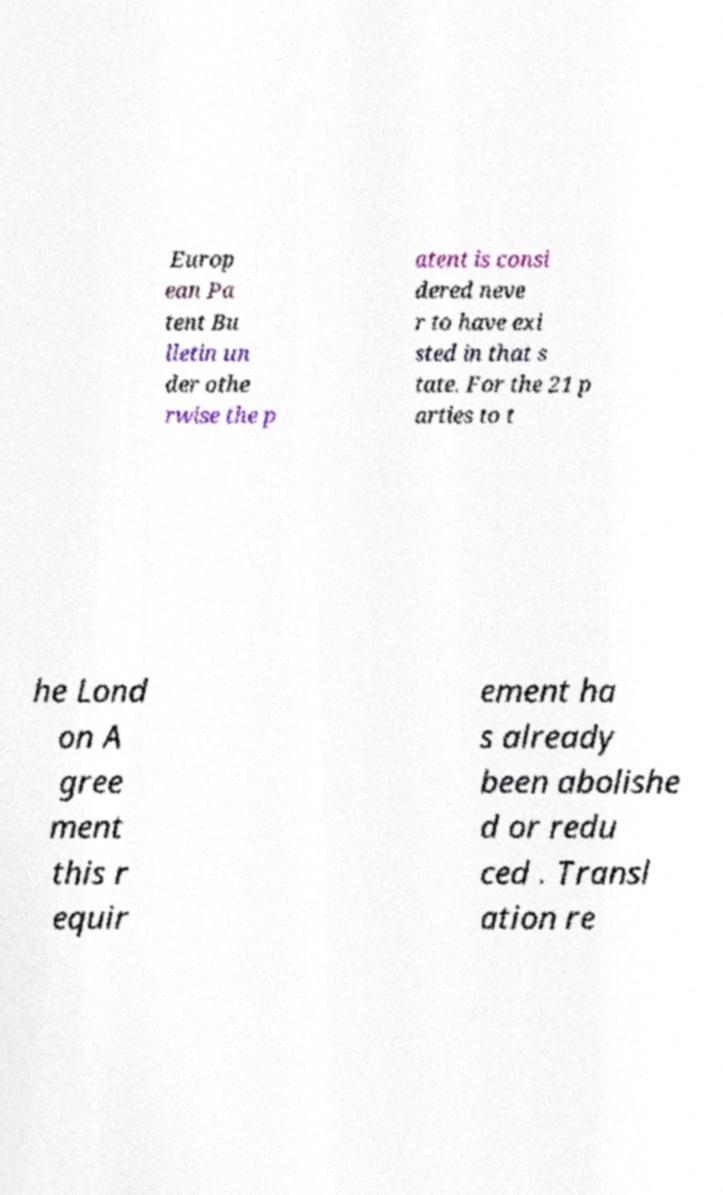Can you accurately transcribe the text from the provided image for me? Europ ean Pa tent Bu lletin un der othe rwise the p atent is consi dered neve r to have exi sted in that s tate. For the 21 p arties to t he Lond on A gree ment this r equir ement ha s already been abolishe d or redu ced . Transl ation re 